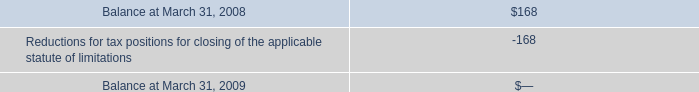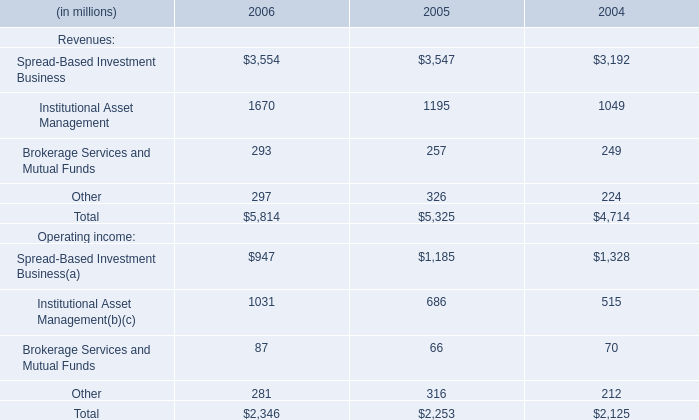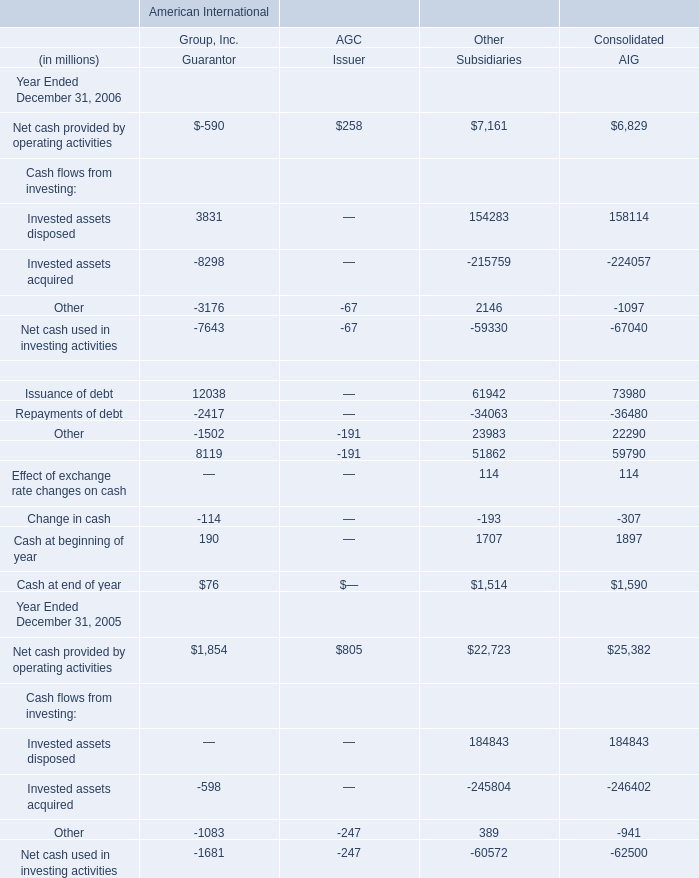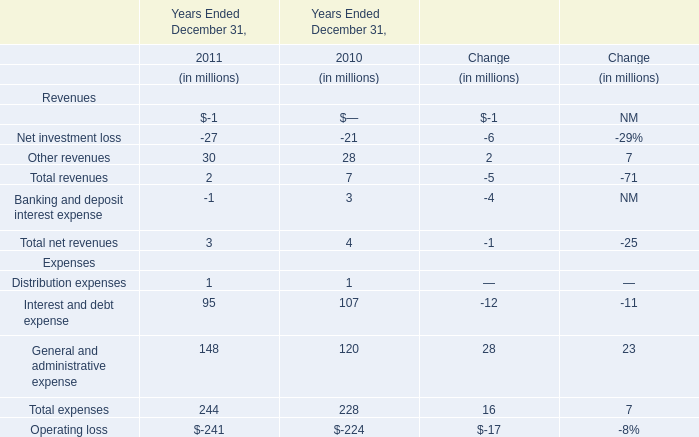What is the sum of the Other revenues in the years where Other revenues is greater than 1? (in million) 
Computations: (30 + 28)
Answer: 58.0. 